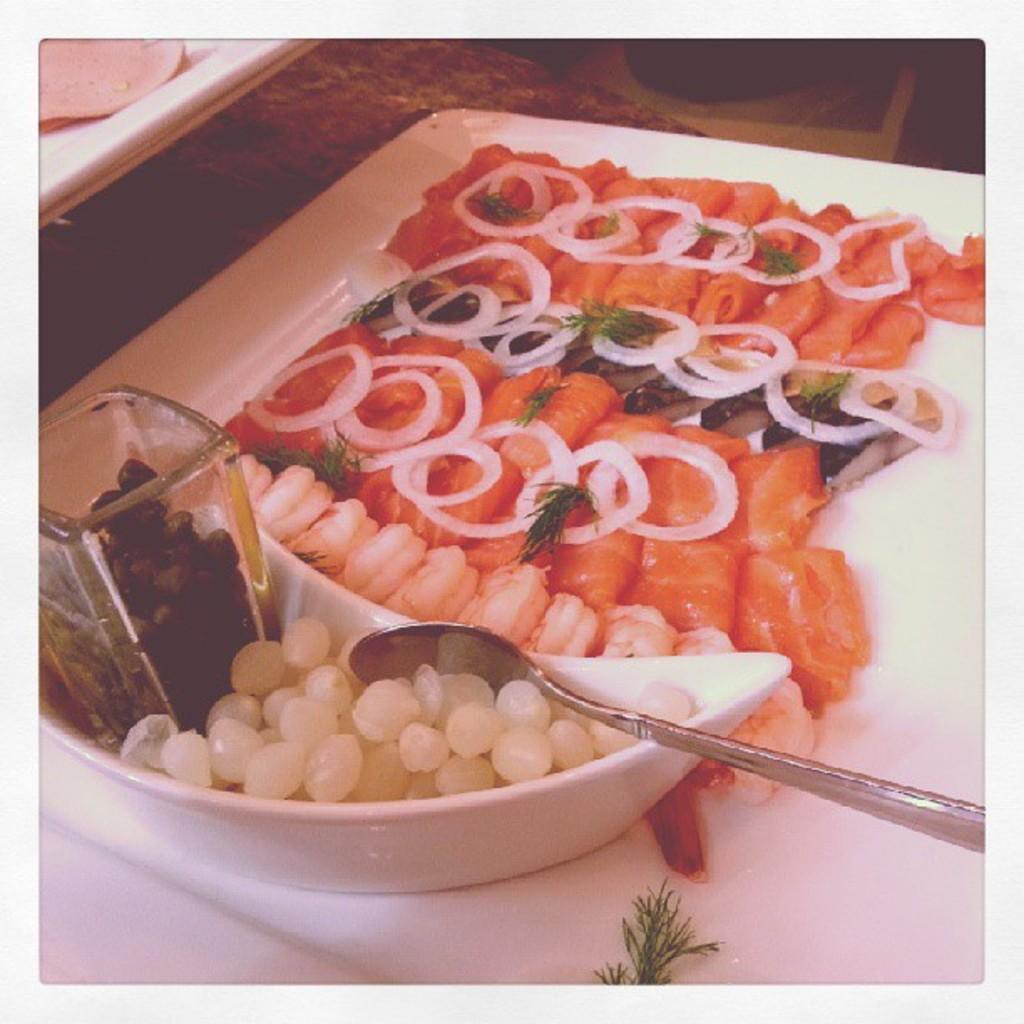What type of dishware can be seen in the image? There is a plate, a bowl, and a glass in the image. What utensil is present in the image? There is a spoon in the image. What types of food are visible in the image? There are different types of food in the image. What color is the white-colored object in the image? The white-colored object in the image is not specified, but it is described as white. What type of operation is being performed on the patient in the image? There is no patient or operation present in the image; it features dishware, utensils, and food. 